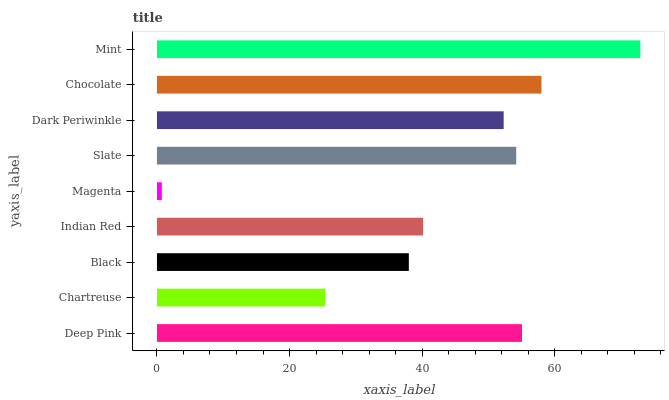Is Magenta the minimum?
Answer yes or no. Yes. Is Mint the maximum?
Answer yes or no. Yes. Is Chartreuse the minimum?
Answer yes or no. No. Is Chartreuse the maximum?
Answer yes or no. No. Is Deep Pink greater than Chartreuse?
Answer yes or no. Yes. Is Chartreuse less than Deep Pink?
Answer yes or no. Yes. Is Chartreuse greater than Deep Pink?
Answer yes or no. No. Is Deep Pink less than Chartreuse?
Answer yes or no. No. Is Dark Periwinkle the high median?
Answer yes or no. Yes. Is Dark Periwinkle the low median?
Answer yes or no. Yes. Is Mint the high median?
Answer yes or no. No. Is Chocolate the low median?
Answer yes or no. No. 